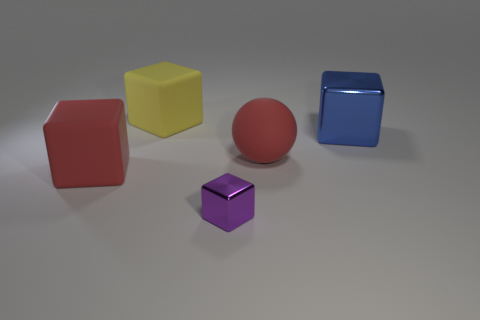Subtract all large blocks. How many blocks are left? 1 Subtract all blue blocks. How many blocks are left? 3 Subtract all brown cubes. Subtract all brown cylinders. How many cubes are left? 4 Add 1 tiny things. How many objects exist? 6 Subtract all blocks. How many objects are left? 1 Subtract 0 green cylinders. How many objects are left? 5 Subtract all big red cylinders. Subtract all matte cubes. How many objects are left? 3 Add 3 small cubes. How many small cubes are left? 4 Add 3 purple shiny objects. How many purple shiny objects exist? 4 